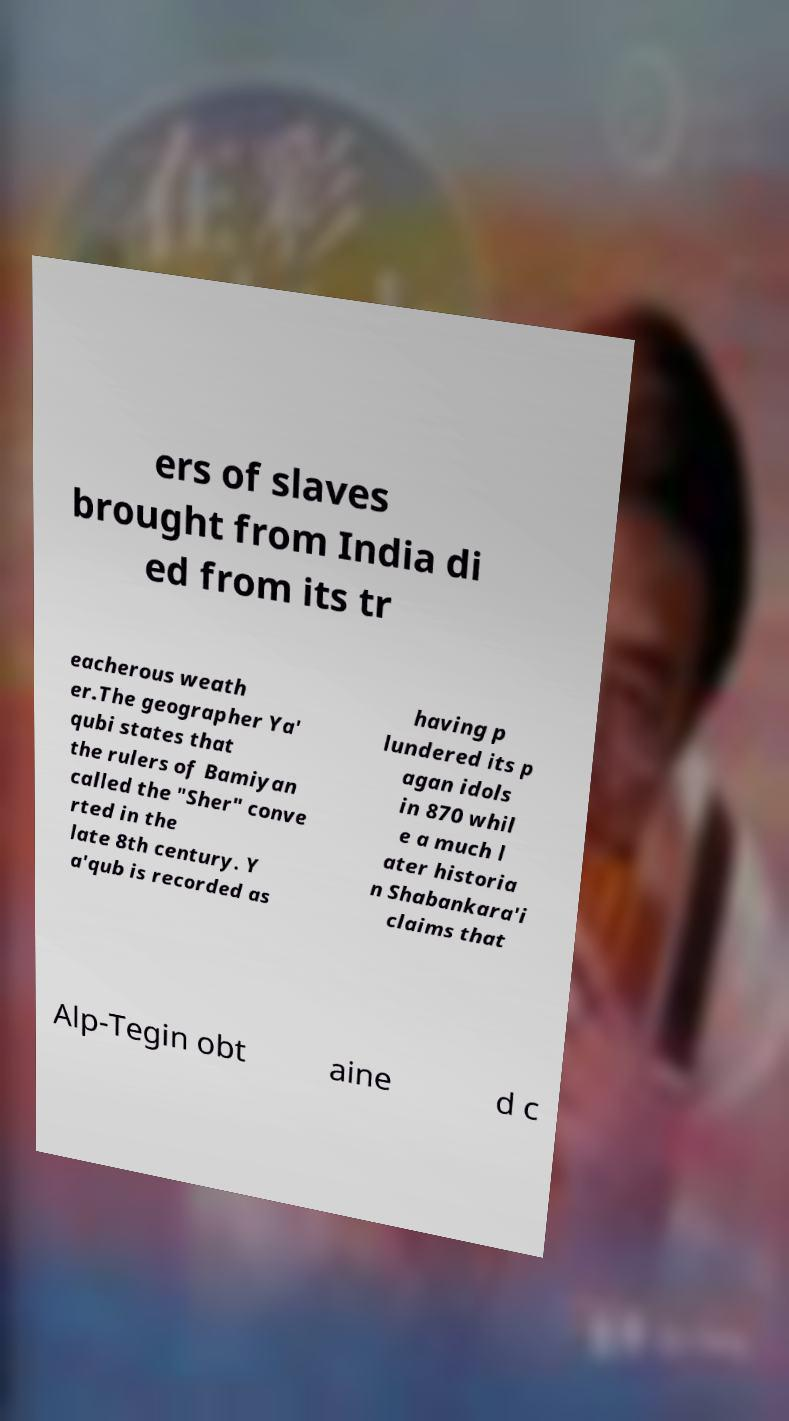There's text embedded in this image that I need extracted. Can you transcribe it verbatim? ers of slaves brought from India di ed from its tr eacherous weath er.The geographer Ya' qubi states that the rulers of Bamiyan called the "Sher" conve rted in the late 8th century. Y a'qub is recorded as having p lundered its p agan idols in 870 whil e a much l ater historia n Shabankara'i claims that Alp-Tegin obt aine d c 